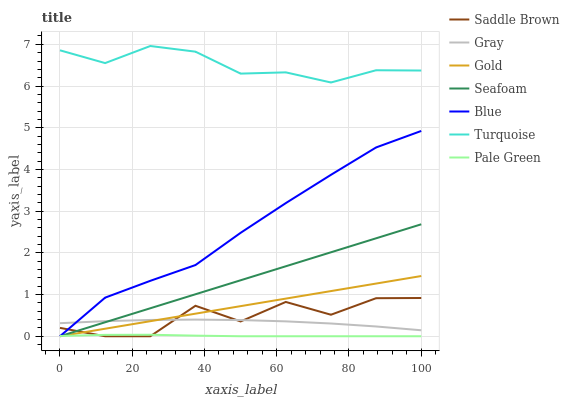Does Pale Green have the minimum area under the curve?
Answer yes or no. Yes. Does Turquoise have the maximum area under the curve?
Answer yes or no. Yes. Does Gray have the minimum area under the curve?
Answer yes or no. No. Does Gray have the maximum area under the curve?
Answer yes or no. No. Is Gold the smoothest?
Answer yes or no. Yes. Is Saddle Brown the roughest?
Answer yes or no. Yes. Is Gray the smoothest?
Answer yes or no. No. Is Gray the roughest?
Answer yes or no. No. Does Blue have the lowest value?
Answer yes or no. Yes. Does Gray have the lowest value?
Answer yes or no. No. Does Turquoise have the highest value?
Answer yes or no. Yes. Does Gray have the highest value?
Answer yes or no. No. Is Pale Green less than Gray?
Answer yes or no. Yes. Is Gray greater than Pale Green?
Answer yes or no. Yes. Does Seafoam intersect Pale Green?
Answer yes or no. Yes. Is Seafoam less than Pale Green?
Answer yes or no. No. Is Seafoam greater than Pale Green?
Answer yes or no. No. Does Pale Green intersect Gray?
Answer yes or no. No. 